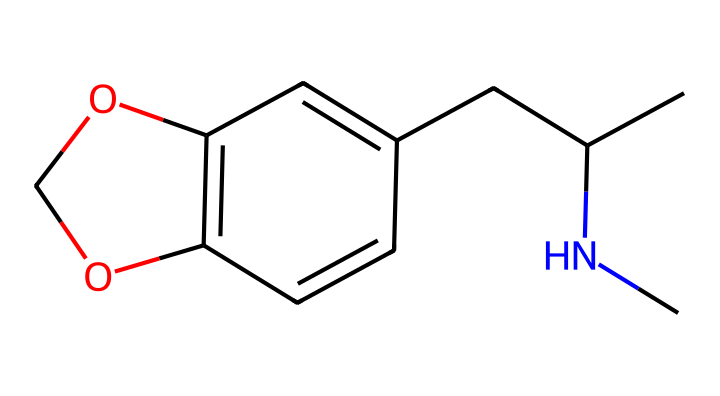What is the central atom in the structure? The central atom in this chemical structure is nitrogen (N), which can be found in the amine functional group.
Answer: nitrogen How many oxygen atoms are present? The chemical structure contains two oxygen atoms, which are represented in the two 'O' symbols in the SMILES.
Answer: two What type of functional group is primarily present in this chemical? The chemical contains an amine group (from the nitrogen atom) and a phenol group (from the presence of the oxygen in a carbon ring structure), but the prominent one is the amine.
Answer: amine What is the molecular formula of this compound? Analyzing the SMILES representation, the molecular formula is C11H15NO2, which indicates the number of carbon (C), hydrogen (H), nitrogen (N), and oxygen (O) atoms present.
Answer: C11H15NO2 What effect does MDMA primarily have on mood? MDMA is known to primarily have an empathogenic effect, which means it enhances feelings of empathy, connection, and emotional warmth.
Answer: empathogenic How does the presence of the nitrogen atom influence the chemical's effects? The presence of the nitrogen atom in this drug structure indicates that MDMA has psychoactive properties, as nitrogen-containing compounds are often linked to neurotransmitter activity in the brain, influencing mood and perception.
Answer: psychoactive What is a potential spiritual experience associated with this chemical? Users often report feelings of oneness and deep connectedness to others and the universe, commonly associated with enhanced spiritual experiences.
Answer: connectedness 